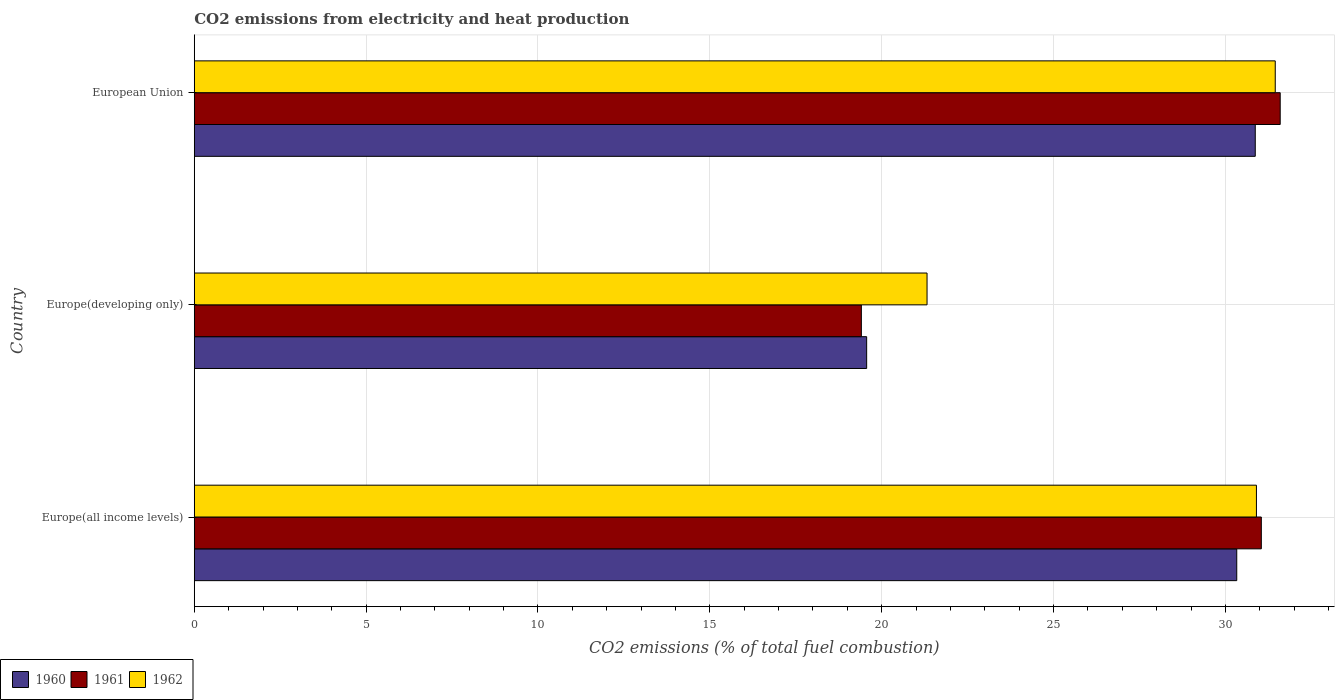How many different coloured bars are there?
Give a very brief answer. 3. Are the number of bars per tick equal to the number of legend labels?
Your response must be concise. Yes. Are the number of bars on each tick of the Y-axis equal?
Give a very brief answer. Yes. How many bars are there on the 1st tick from the top?
Keep it short and to the point. 3. What is the label of the 3rd group of bars from the top?
Make the answer very short. Europe(all income levels). In how many cases, is the number of bars for a given country not equal to the number of legend labels?
Offer a very short reply. 0. What is the amount of CO2 emitted in 1960 in Europe(all income levels)?
Your response must be concise. 30.33. Across all countries, what is the maximum amount of CO2 emitted in 1962?
Your answer should be very brief. 31.45. Across all countries, what is the minimum amount of CO2 emitted in 1962?
Provide a succinct answer. 21.32. In which country was the amount of CO2 emitted in 1962 maximum?
Give a very brief answer. European Union. In which country was the amount of CO2 emitted in 1961 minimum?
Keep it short and to the point. Europe(developing only). What is the total amount of CO2 emitted in 1960 in the graph?
Your answer should be compact. 80.76. What is the difference between the amount of CO2 emitted in 1962 in Europe(all income levels) and that in European Union?
Offer a very short reply. -0.55. What is the difference between the amount of CO2 emitted in 1962 in Europe(developing only) and the amount of CO2 emitted in 1960 in Europe(all income levels)?
Your answer should be compact. -9.01. What is the average amount of CO2 emitted in 1962 per country?
Provide a succinct answer. 27.89. What is the difference between the amount of CO2 emitted in 1961 and amount of CO2 emitted in 1962 in European Union?
Your response must be concise. 0.14. In how many countries, is the amount of CO2 emitted in 1961 greater than 27 %?
Your response must be concise. 2. What is the ratio of the amount of CO2 emitted in 1962 in Europe(all income levels) to that in Europe(developing only)?
Offer a terse response. 1.45. Is the amount of CO2 emitted in 1962 in Europe(all income levels) less than that in European Union?
Offer a very short reply. Yes. What is the difference between the highest and the second highest amount of CO2 emitted in 1961?
Provide a succinct answer. 0.55. What is the difference between the highest and the lowest amount of CO2 emitted in 1961?
Offer a terse response. 12.19. Is the sum of the amount of CO2 emitted in 1962 in Europe(all income levels) and European Union greater than the maximum amount of CO2 emitted in 1960 across all countries?
Provide a short and direct response. Yes. What does the 1st bar from the top in Europe(developing only) represents?
Make the answer very short. 1962. What does the 1st bar from the bottom in Europe(all income levels) represents?
Offer a terse response. 1960. Is it the case that in every country, the sum of the amount of CO2 emitted in 1962 and amount of CO2 emitted in 1960 is greater than the amount of CO2 emitted in 1961?
Your answer should be very brief. Yes. Are all the bars in the graph horizontal?
Provide a short and direct response. Yes. Does the graph contain any zero values?
Give a very brief answer. No. How many legend labels are there?
Ensure brevity in your answer.  3. How are the legend labels stacked?
Ensure brevity in your answer.  Horizontal. What is the title of the graph?
Your answer should be very brief. CO2 emissions from electricity and heat production. What is the label or title of the X-axis?
Keep it short and to the point. CO2 emissions (% of total fuel combustion). What is the CO2 emissions (% of total fuel combustion) of 1960 in Europe(all income levels)?
Keep it short and to the point. 30.33. What is the CO2 emissions (% of total fuel combustion) of 1961 in Europe(all income levels)?
Your response must be concise. 31.04. What is the CO2 emissions (% of total fuel combustion) of 1962 in Europe(all income levels)?
Keep it short and to the point. 30.9. What is the CO2 emissions (% of total fuel combustion) in 1960 in Europe(developing only)?
Provide a succinct answer. 19.56. What is the CO2 emissions (% of total fuel combustion) in 1961 in Europe(developing only)?
Provide a succinct answer. 19.41. What is the CO2 emissions (% of total fuel combustion) of 1962 in Europe(developing only)?
Offer a very short reply. 21.32. What is the CO2 emissions (% of total fuel combustion) in 1960 in European Union?
Offer a terse response. 30.87. What is the CO2 emissions (% of total fuel combustion) of 1961 in European Union?
Keep it short and to the point. 31.59. What is the CO2 emissions (% of total fuel combustion) of 1962 in European Union?
Your answer should be very brief. 31.45. Across all countries, what is the maximum CO2 emissions (% of total fuel combustion) of 1960?
Provide a succinct answer. 30.87. Across all countries, what is the maximum CO2 emissions (% of total fuel combustion) of 1961?
Ensure brevity in your answer.  31.59. Across all countries, what is the maximum CO2 emissions (% of total fuel combustion) of 1962?
Your answer should be very brief. 31.45. Across all countries, what is the minimum CO2 emissions (% of total fuel combustion) in 1960?
Keep it short and to the point. 19.56. Across all countries, what is the minimum CO2 emissions (% of total fuel combustion) of 1961?
Offer a very short reply. 19.41. Across all countries, what is the minimum CO2 emissions (% of total fuel combustion) of 1962?
Offer a very short reply. 21.32. What is the total CO2 emissions (% of total fuel combustion) of 1960 in the graph?
Your answer should be very brief. 80.76. What is the total CO2 emissions (% of total fuel combustion) of 1961 in the graph?
Give a very brief answer. 82.05. What is the total CO2 emissions (% of total fuel combustion) in 1962 in the graph?
Keep it short and to the point. 83.67. What is the difference between the CO2 emissions (% of total fuel combustion) in 1960 in Europe(all income levels) and that in Europe(developing only)?
Offer a very short reply. 10.77. What is the difference between the CO2 emissions (% of total fuel combustion) in 1961 in Europe(all income levels) and that in Europe(developing only)?
Ensure brevity in your answer.  11.64. What is the difference between the CO2 emissions (% of total fuel combustion) in 1962 in Europe(all income levels) and that in Europe(developing only)?
Ensure brevity in your answer.  9.58. What is the difference between the CO2 emissions (% of total fuel combustion) of 1960 in Europe(all income levels) and that in European Union?
Provide a succinct answer. -0.54. What is the difference between the CO2 emissions (% of total fuel combustion) of 1961 in Europe(all income levels) and that in European Union?
Your response must be concise. -0.55. What is the difference between the CO2 emissions (% of total fuel combustion) of 1962 in Europe(all income levels) and that in European Union?
Offer a terse response. -0.55. What is the difference between the CO2 emissions (% of total fuel combustion) of 1960 in Europe(developing only) and that in European Union?
Provide a succinct answer. -11.31. What is the difference between the CO2 emissions (% of total fuel combustion) in 1961 in Europe(developing only) and that in European Union?
Give a very brief answer. -12.19. What is the difference between the CO2 emissions (% of total fuel combustion) in 1962 in Europe(developing only) and that in European Union?
Your response must be concise. -10.13. What is the difference between the CO2 emissions (% of total fuel combustion) in 1960 in Europe(all income levels) and the CO2 emissions (% of total fuel combustion) in 1961 in Europe(developing only)?
Offer a very short reply. 10.92. What is the difference between the CO2 emissions (% of total fuel combustion) in 1960 in Europe(all income levels) and the CO2 emissions (% of total fuel combustion) in 1962 in Europe(developing only)?
Keep it short and to the point. 9.01. What is the difference between the CO2 emissions (% of total fuel combustion) in 1961 in Europe(all income levels) and the CO2 emissions (% of total fuel combustion) in 1962 in Europe(developing only)?
Offer a very short reply. 9.73. What is the difference between the CO2 emissions (% of total fuel combustion) in 1960 in Europe(all income levels) and the CO2 emissions (% of total fuel combustion) in 1961 in European Union?
Provide a succinct answer. -1.26. What is the difference between the CO2 emissions (% of total fuel combustion) in 1960 in Europe(all income levels) and the CO2 emissions (% of total fuel combustion) in 1962 in European Union?
Make the answer very short. -1.12. What is the difference between the CO2 emissions (% of total fuel combustion) in 1961 in Europe(all income levels) and the CO2 emissions (% of total fuel combustion) in 1962 in European Union?
Give a very brief answer. -0.41. What is the difference between the CO2 emissions (% of total fuel combustion) of 1960 in Europe(developing only) and the CO2 emissions (% of total fuel combustion) of 1961 in European Union?
Offer a terse response. -12.03. What is the difference between the CO2 emissions (% of total fuel combustion) of 1960 in Europe(developing only) and the CO2 emissions (% of total fuel combustion) of 1962 in European Union?
Keep it short and to the point. -11.89. What is the difference between the CO2 emissions (% of total fuel combustion) of 1961 in Europe(developing only) and the CO2 emissions (% of total fuel combustion) of 1962 in European Union?
Provide a short and direct response. -12.04. What is the average CO2 emissions (% of total fuel combustion) of 1960 per country?
Make the answer very short. 26.92. What is the average CO2 emissions (% of total fuel combustion) of 1961 per country?
Give a very brief answer. 27.35. What is the average CO2 emissions (% of total fuel combustion) in 1962 per country?
Your answer should be compact. 27.89. What is the difference between the CO2 emissions (% of total fuel combustion) of 1960 and CO2 emissions (% of total fuel combustion) of 1961 in Europe(all income levels)?
Offer a very short reply. -0.71. What is the difference between the CO2 emissions (% of total fuel combustion) in 1960 and CO2 emissions (% of total fuel combustion) in 1962 in Europe(all income levels)?
Your answer should be compact. -0.57. What is the difference between the CO2 emissions (% of total fuel combustion) in 1961 and CO2 emissions (% of total fuel combustion) in 1962 in Europe(all income levels)?
Your answer should be compact. 0.14. What is the difference between the CO2 emissions (% of total fuel combustion) of 1960 and CO2 emissions (% of total fuel combustion) of 1961 in Europe(developing only)?
Your answer should be compact. 0.15. What is the difference between the CO2 emissions (% of total fuel combustion) of 1960 and CO2 emissions (% of total fuel combustion) of 1962 in Europe(developing only)?
Offer a very short reply. -1.76. What is the difference between the CO2 emissions (% of total fuel combustion) of 1961 and CO2 emissions (% of total fuel combustion) of 1962 in Europe(developing only)?
Your response must be concise. -1.91. What is the difference between the CO2 emissions (% of total fuel combustion) in 1960 and CO2 emissions (% of total fuel combustion) in 1961 in European Union?
Provide a succinct answer. -0.73. What is the difference between the CO2 emissions (% of total fuel combustion) in 1960 and CO2 emissions (% of total fuel combustion) in 1962 in European Union?
Your answer should be compact. -0.58. What is the difference between the CO2 emissions (% of total fuel combustion) of 1961 and CO2 emissions (% of total fuel combustion) of 1962 in European Union?
Ensure brevity in your answer.  0.14. What is the ratio of the CO2 emissions (% of total fuel combustion) of 1960 in Europe(all income levels) to that in Europe(developing only)?
Your answer should be compact. 1.55. What is the ratio of the CO2 emissions (% of total fuel combustion) of 1961 in Europe(all income levels) to that in Europe(developing only)?
Keep it short and to the point. 1.6. What is the ratio of the CO2 emissions (% of total fuel combustion) in 1962 in Europe(all income levels) to that in Europe(developing only)?
Your response must be concise. 1.45. What is the ratio of the CO2 emissions (% of total fuel combustion) of 1960 in Europe(all income levels) to that in European Union?
Provide a short and direct response. 0.98. What is the ratio of the CO2 emissions (% of total fuel combustion) in 1961 in Europe(all income levels) to that in European Union?
Give a very brief answer. 0.98. What is the ratio of the CO2 emissions (% of total fuel combustion) in 1962 in Europe(all income levels) to that in European Union?
Keep it short and to the point. 0.98. What is the ratio of the CO2 emissions (% of total fuel combustion) of 1960 in Europe(developing only) to that in European Union?
Ensure brevity in your answer.  0.63. What is the ratio of the CO2 emissions (% of total fuel combustion) in 1961 in Europe(developing only) to that in European Union?
Offer a very short reply. 0.61. What is the ratio of the CO2 emissions (% of total fuel combustion) of 1962 in Europe(developing only) to that in European Union?
Your answer should be very brief. 0.68. What is the difference between the highest and the second highest CO2 emissions (% of total fuel combustion) of 1960?
Provide a short and direct response. 0.54. What is the difference between the highest and the second highest CO2 emissions (% of total fuel combustion) of 1961?
Provide a short and direct response. 0.55. What is the difference between the highest and the second highest CO2 emissions (% of total fuel combustion) of 1962?
Keep it short and to the point. 0.55. What is the difference between the highest and the lowest CO2 emissions (% of total fuel combustion) in 1960?
Provide a short and direct response. 11.31. What is the difference between the highest and the lowest CO2 emissions (% of total fuel combustion) in 1961?
Your answer should be very brief. 12.19. What is the difference between the highest and the lowest CO2 emissions (% of total fuel combustion) in 1962?
Your answer should be very brief. 10.13. 